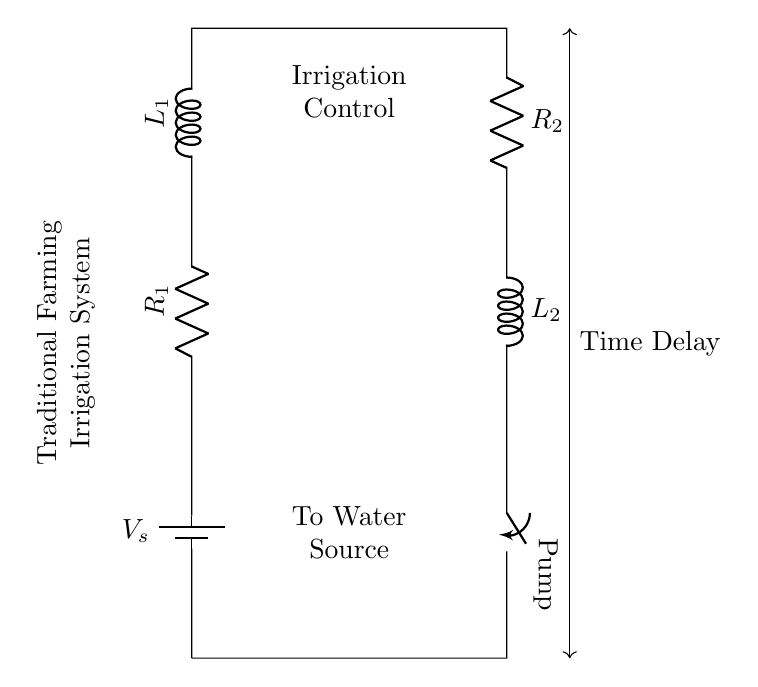What are the components used in this circuit? The circuit includes a voltage source, two resistors, two inductors, and a switch labeled 'Pump'. These components work together to control the timing of the irrigation pump.
Answer: voltage source, two resistors, two inductors, switch What is the purpose of the switch labeled 'Pump'? The switch in the circuit controls the irrigation pump, allowing it to turn on or off based on the timing determined by the resistors and inductors.
Answer: control the pump How many resistors are present in the circuit? There are two resistors labeled R1 and R2 in the circuit diagram, which are used to control the timing and current flow for the irrigation system.
Answer: two What is the type of circuit depicted in the diagram? This is a resistor-inductor circuit because it combines resistors and inductors to manage the timing for the irrigation pump's operation through energy storage and release.
Answer: resistor-inductor What could be a benefit of using a resistor-inductor circuit for irrigation timing? The resistor-inductor circuit can offer controlled and delayed activation of the irrigation pump, providing efficient water usage by preventing immediate and excessive water flow.
Answer: efficient water usage How does the inductor affect the timing of the irrigation system? The inductor stores energy in a magnetic field when current flows through it, which creates a delay in the current reaching the pump when the circuit is activated, thus influencing the timing of irrigation.
Answer: creates a delay What does the 'Time Delay' notation signify in this circuit? The 'Time Delay' notation indicates the characteristic behavior of the circuit for controlling the irrigation timing, meaning there is a delay before the pump activates after the circuit is closed.
Answer: circuit delay 